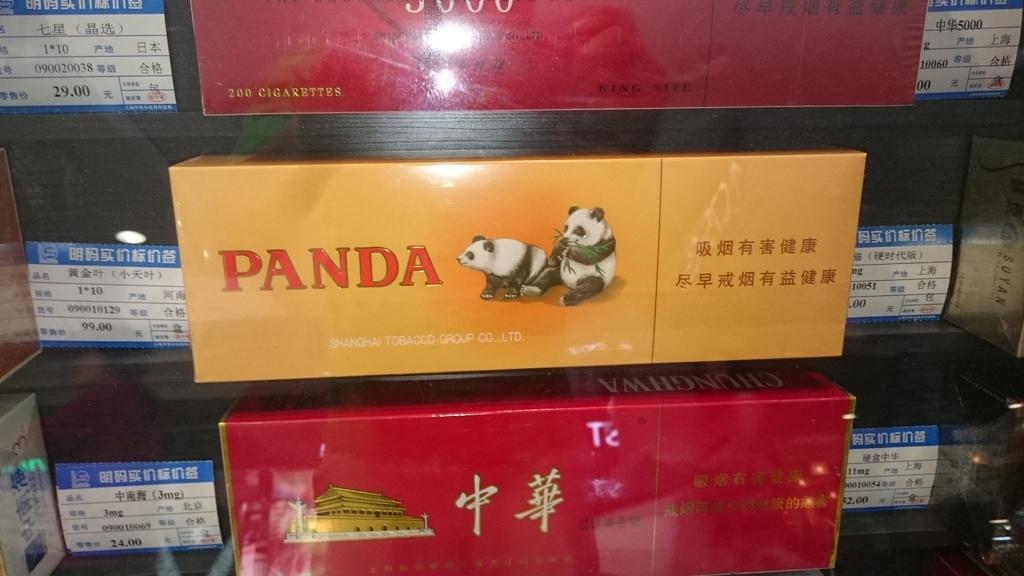Could you give a brief overview of what you see in this image? As we can see in the image there are different colors of boxes. On boxes there is something written. 